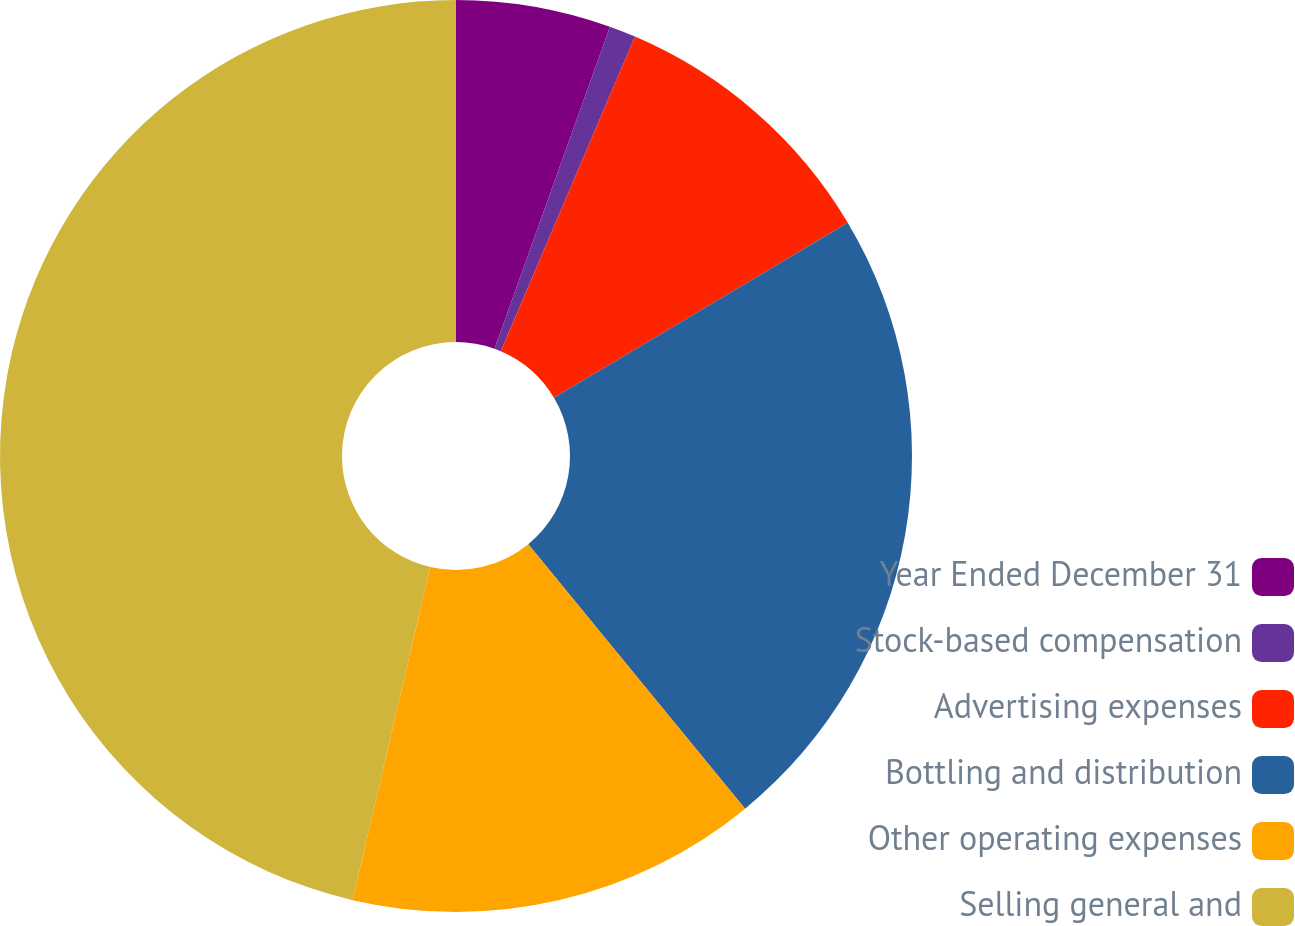Convert chart to OTSL. <chart><loc_0><loc_0><loc_500><loc_500><pie_chart><fcel>Year Ended December 31<fcel>Stock-based compensation<fcel>Advertising expenses<fcel>Bottling and distribution<fcel>Other operating expenses<fcel>Selling general and<nl><fcel>5.48%<fcel>0.94%<fcel>10.03%<fcel>22.62%<fcel>14.57%<fcel>46.36%<nl></chart> 